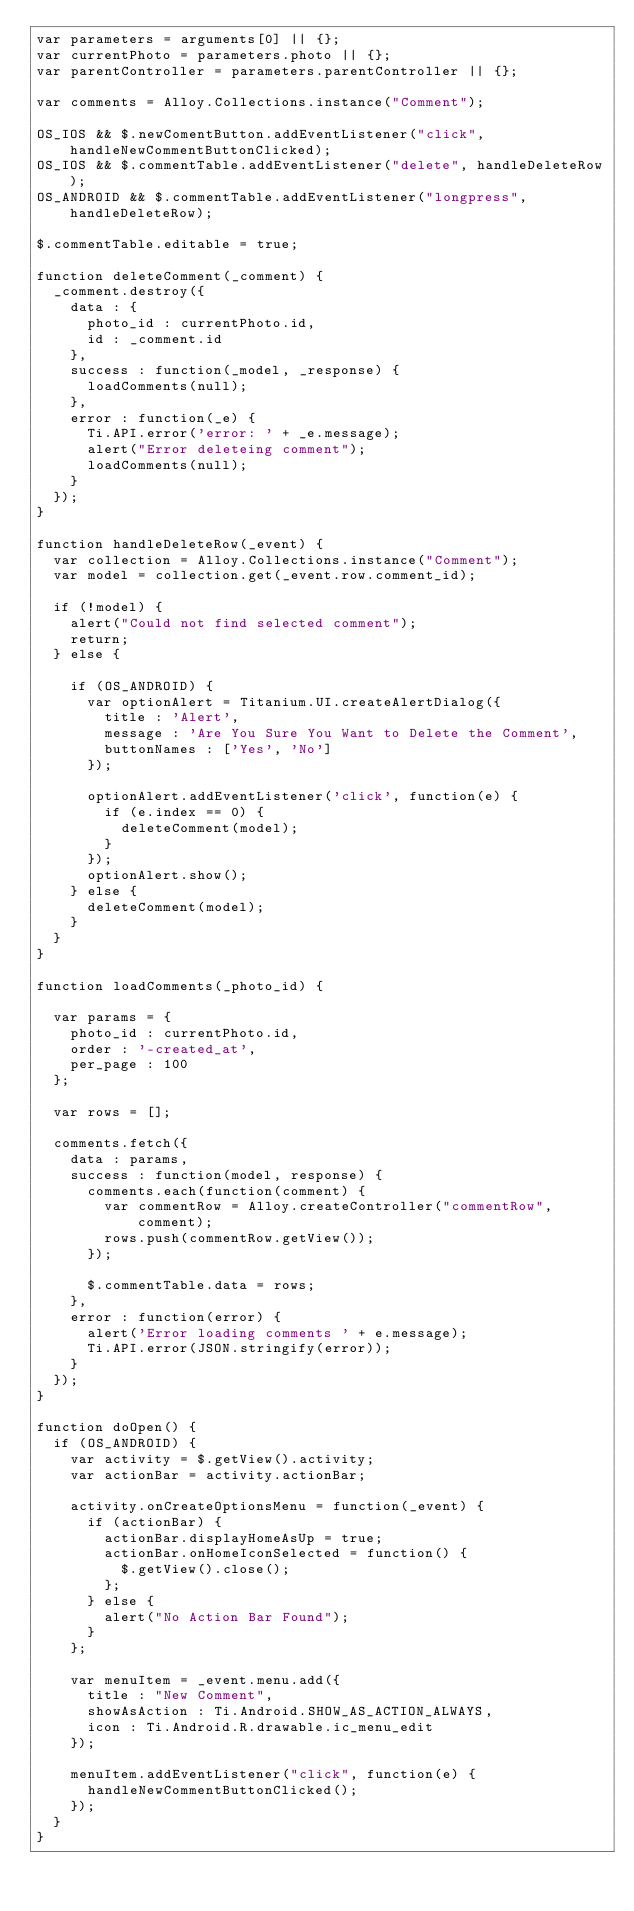<code> <loc_0><loc_0><loc_500><loc_500><_JavaScript_>var parameters = arguments[0] || {};
var currentPhoto = parameters.photo || {};
var parentController = parameters.parentController || {};

var comments = Alloy.Collections.instance("Comment");

OS_IOS && $.newComentButton.addEventListener("click", handleNewCommentButtonClicked);
OS_IOS && $.commentTable.addEventListener("delete", handleDeleteRow);
OS_ANDROID && $.commentTable.addEventListener("longpress", handleDeleteRow);

$.commentTable.editable = true;

function deleteComment(_comment) {
	_comment.destroy({
		data : {
			photo_id : currentPhoto.id,
			id : _comment.id
		},
		success : function(_model, _response) {
			loadComments(null);
		},
		error : function(_e) {
			Ti.API.error('error: ' + _e.message);
			alert("Error deleteing comment");
			loadComments(null);
		}
	});
}

function handleDeleteRow(_event) {
	var collection = Alloy.Collections.instance("Comment");
	var model = collection.get(_event.row.comment_id);

	if (!model) {
		alert("Could not find selected comment");
		return;
	} else {

		if (OS_ANDROID) {
			var optionAlert = Titanium.UI.createAlertDialog({
				title : 'Alert',
				message : 'Are You Sure You Want to Delete the Comment',
				buttonNames : ['Yes', 'No']
			});

			optionAlert.addEventListener('click', function(e) {
				if (e.index == 0) {
					deleteComment(model);
				}
			});
			optionAlert.show();
		} else {
			deleteComment(model);
		}
	}
}

function loadComments(_photo_id) {

	var params = {
		photo_id : currentPhoto.id,
		order : '-created_at',
		per_page : 100
	};

	var rows = [];

	comments.fetch({
		data : params,
		success : function(model, response) {
			comments.each(function(comment) {
				var commentRow = Alloy.createController("commentRow", comment);
				rows.push(commentRow.getView());
			});

			$.commentTable.data = rows;
		},
		error : function(error) {
			alert('Error loading comments ' + e.message);
			Ti.API.error(JSON.stringify(error));
		}
	});
}

function doOpen() {
	if (OS_ANDROID) {
		var activity = $.getView().activity;
		var actionBar = activity.actionBar;

		activity.onCreateOptionsMenu = function(_event) {
			if (actionBar) {
				actionBar.displayHomeAsUp = true;
				actionBar.onHomeIconSelected = function() {
					$.getView().close();
				};
			} else {
				alert("No Action Bar Found");
			}
		};

		var menuItem = _event.menu.add({
			title : "New Comment",
			showAsAction : Ti.Android.SHOW_AS_ACTION_ALWAYS,
			icon : Ti.Android.R.drawable.ic_menu_edit
		});

		menuItem.addEventListener("click", function(e) {
			handleNewCommentButtonClicked();
		});
	}
}

</code> 